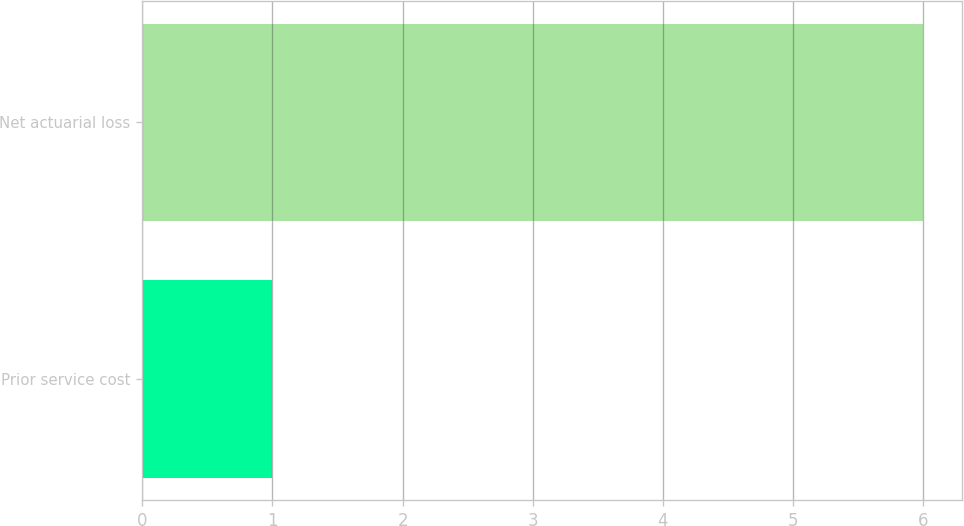Convert chart. <chart><loc_0><loc_0><loc_500><loc_500><bar_chart><fcel>Prior service cost<fcel>Net actuarial loss<nl><fcel>1<fcel>6<nl></chart> 